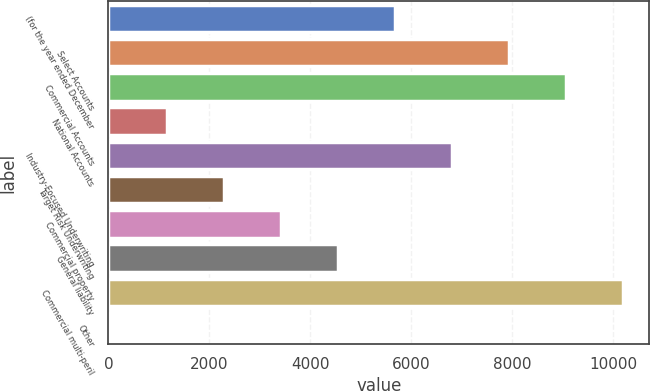<chart> <loc_0><loc_0><loc_500><loc_500><bar_chart><fcel>(for the year ended December<fcel>Select Accounts<fcel>Commercial Accounts<fcel>National Accounts<fcel>Industry-Focused Underwriting<fcel>Target Risk Underwriting<fcel>Commercial property<fcel>General liability<fcel>Commercial multi-peril<fcel>Other<nl><fcel>5685<fcel>7947<fcel>9078<fcel>1161<fcel>6816<fcel>2292<fcel>3423<fcel>4554<fcel>10209<fcel>30<nl></chart> 